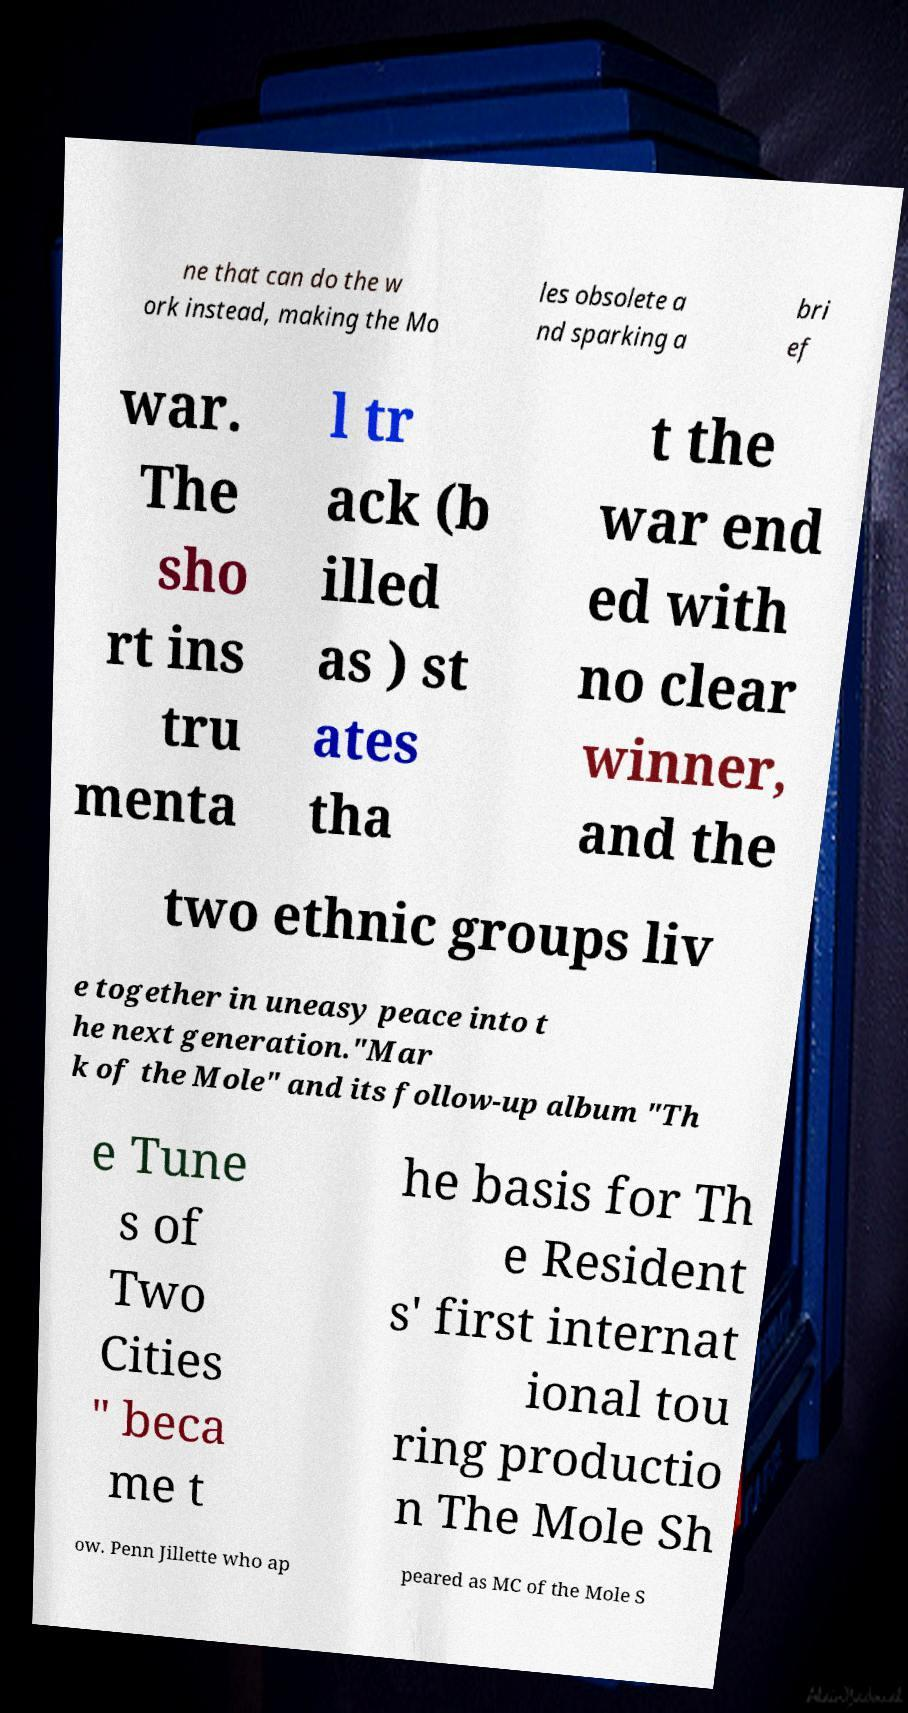Can you accurately transcribe the text from the provided image for me? ne that can do the w ork instead, making the Mo les obsolete a nd sparking a bri ef war. The sho rt ins tru menta l tr ack (b illed as ) st ates tha t the war end ed with no clear winner, and the two ethnic groups liv e together in uneasy peace into t he next generation."Mar k of the Mole" and its follow-up album "Th e Tune s of Two Cities " beca me t he basis for Th e Resident s' first internat ional tou ring productio n The Mole Sh ow. Penn Jillette who ap peared as MC of the Mole S 